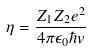Convert formula to latex. <formula><loc_0><loc_0><loc_500><loc_500>\eta = \frac { Z _ { 1 } Z _ { 2 } e ^ { 2 } } { 4 \pi \epsilon _ { 0 } \hbar { v } }</formula> 